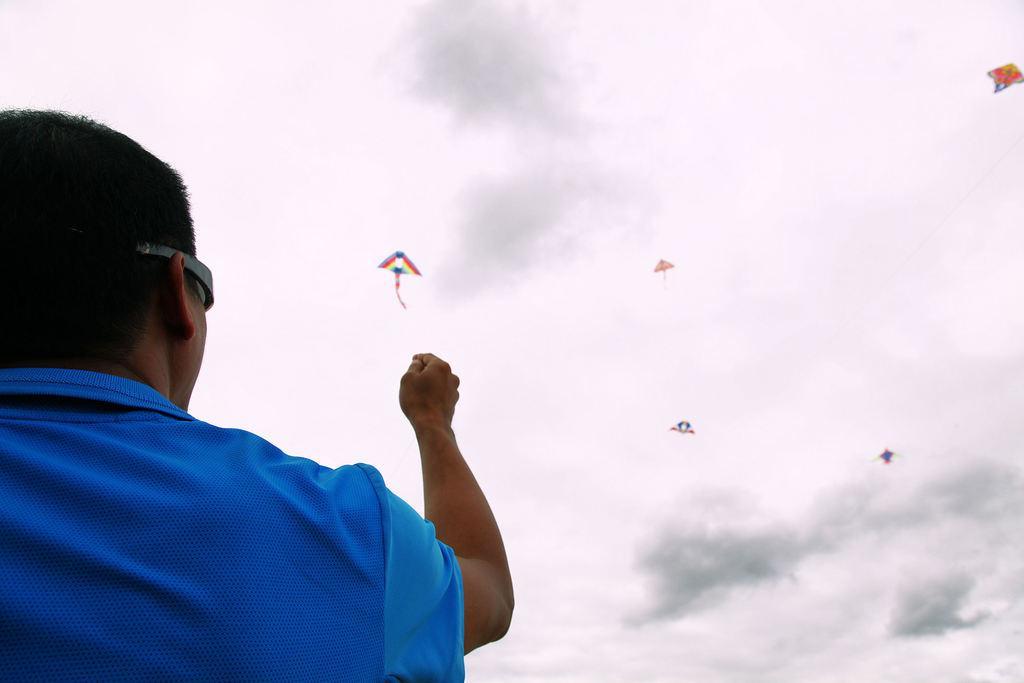Could you give a brief overview of what you see in this image? This picture consists of person on the left side , in the middle I can see there are kites and the sky visible. 